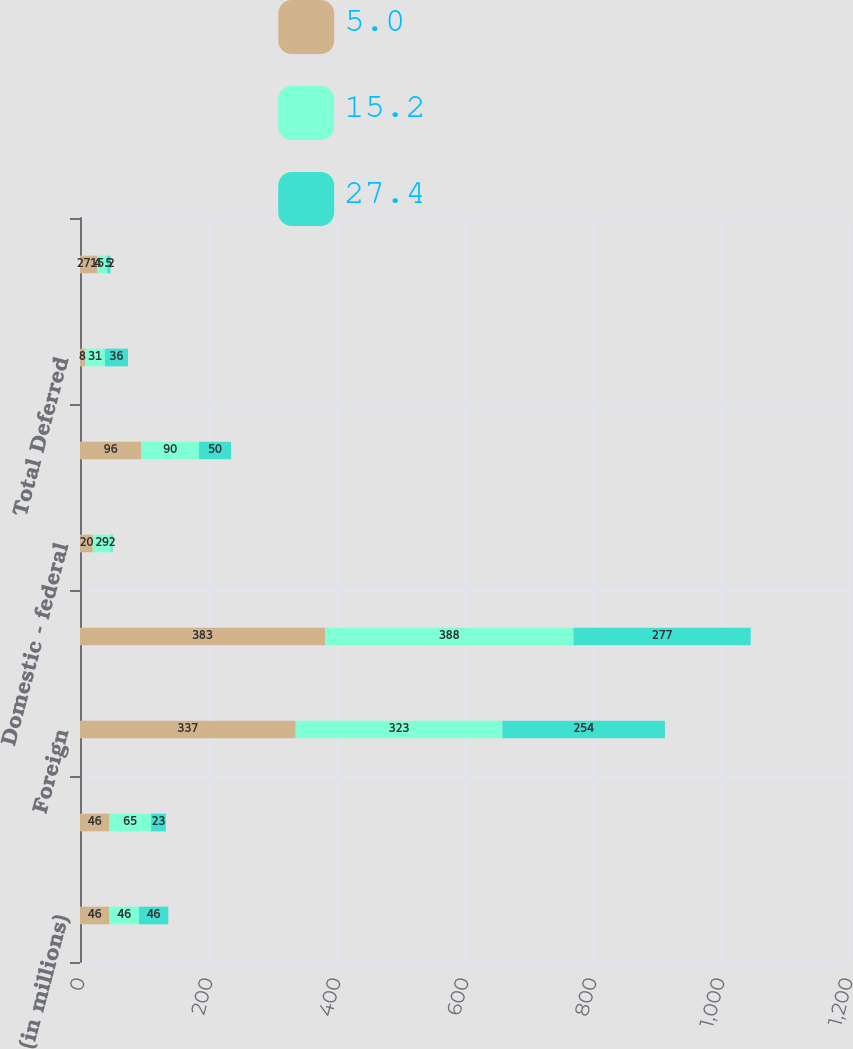<chart> <loc_0><loc_0><loc_500><loc_500><stacked_bar_chart><ecel><fcel>(in millions)<fcel>Domestic<fcel>Foreign<fcel>Total pre-tax income<fcel>Domestic - federal<fcel>Total Current<fcel>Total Deferred<fcel>Effective income tax rate<nl><fcel>5<fcel>46<fcel>46<fcel>337<fcel>383<fcel>20<fcel>96<fcel>8<fcel>27.4<nl><fcel>15.2<fcel>46<fcel>65<fcel>323<fcel>388<fcel>29<fcel>90<fcel>31<fcel>15.2<nl><fcel>27.4<fcel>46<fcel>23<fcel>254<fcel>277<fcel>2<fcel>50<fcel>36<fcel>5<nl></chart> 